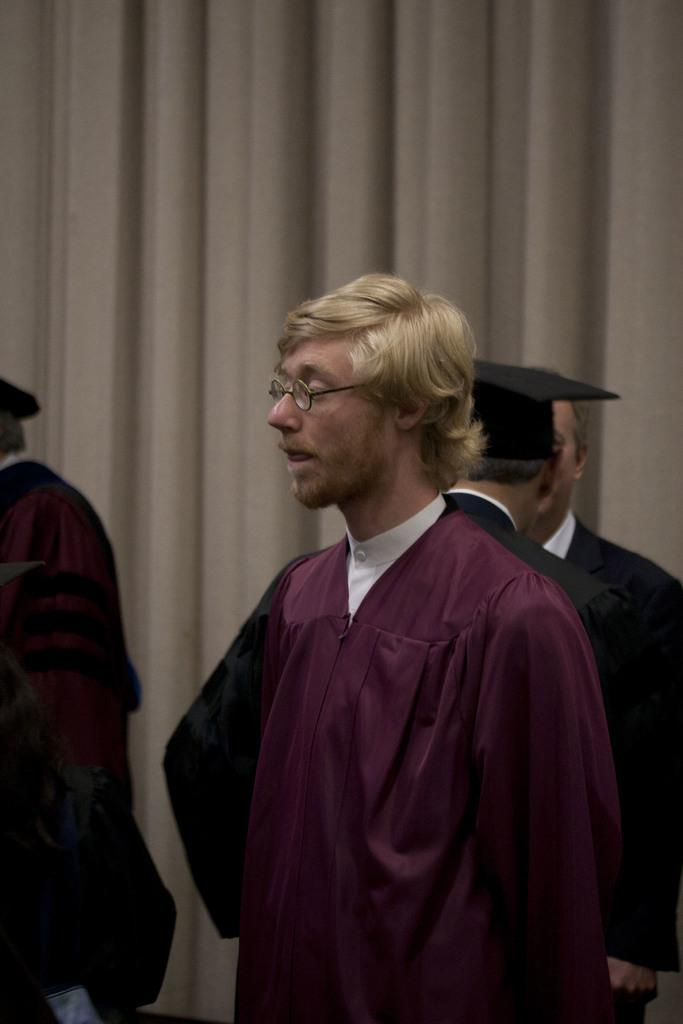What is the man in the image wearing? The man is wearing a graduation dress. Who else is present in the image besides the man? There are people standing at the back in the image. What can be seen hanging in the background of the image? There is a curtain in the image. What type of shelf can be seen in the image? There is no shelf present in the image. 